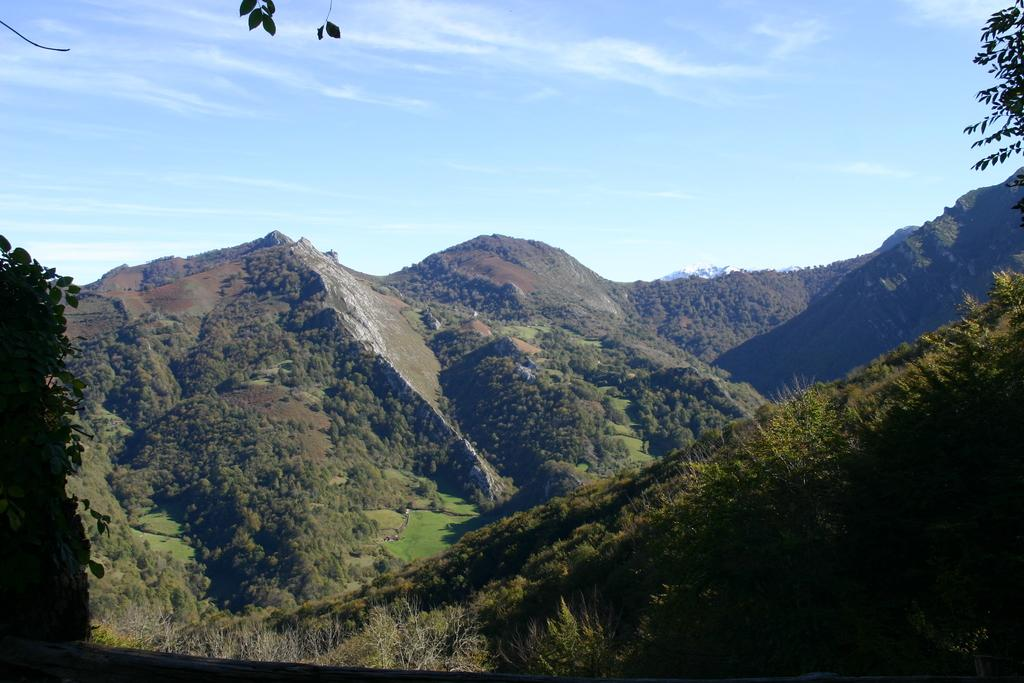What type of landscape feature can be seen in the image? There are hills in the image. What type of vegetation is present in the image? There are trees in the image. What is visible at the top of the image? The sky is visible at the top of the image. What color is the orange hanging from the tree in the image? There is no orange present in the image; it only features hills and trees. 